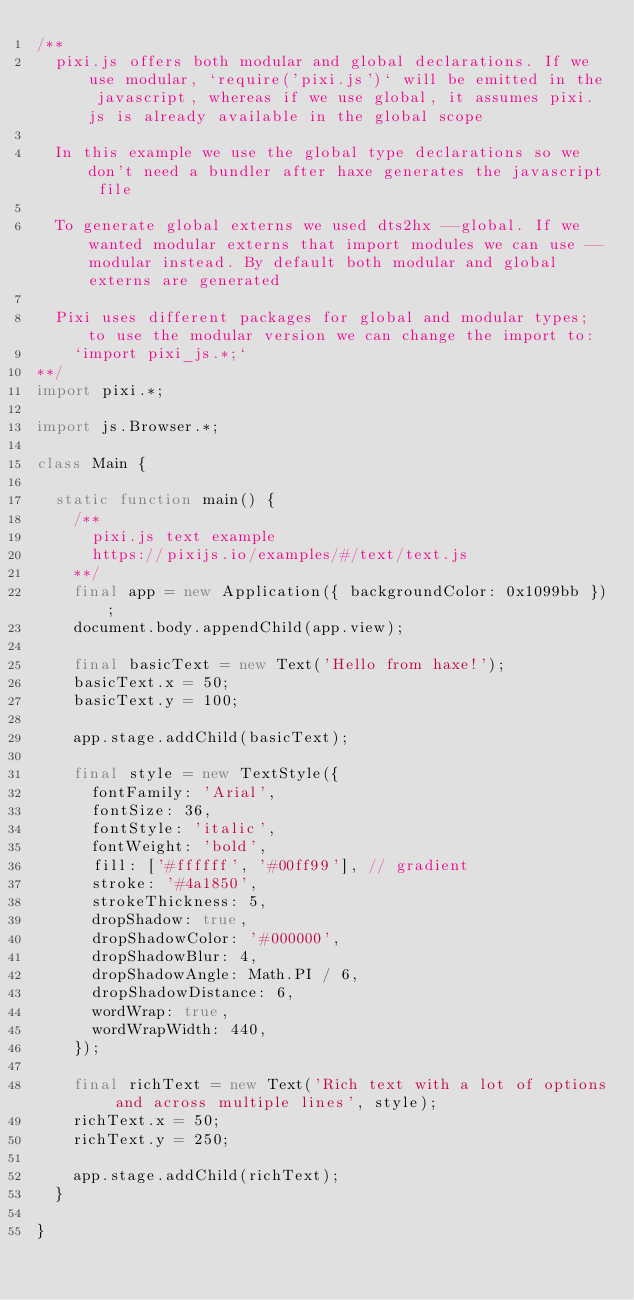Convert code to text. <code><loc_0><loc_0><loc_500><loc_500><_Haxe_>/**
	pixi.js offers both modular and global declarations. If we use modular, `require('pixi.js')` will be emitted in the javascript, whereas if we use global, it assumes pixi.js is already available in the global scope

	In this example we use the global type declarations so we don't need a bundler after haxe generates the javascript file

	To generate global externs we used dts2hx --global. If we wanted modular externs that import modules we can use --modular instead. By default both modular and global externs are generated

	Pixi uses different packages for global and modular types; to use the modular version we can change the import to:
		`import pixi_js.*;`
**/
import pixi.*;

import js.Browser.*;

class Main {

	static function main() {
		/**
			pixi.js text example
			https://pixijs.io/examples/#/text/text.js
		**/
		final app = new Application({ backgroundColor: 0x1099bb });
		document.body.appendChild(app.view);

		final basicText = new Text('Hello from haxe!');
		basicText.x = 50;
		basicText.y = 100;

		app.stage.addChild(basicText);

		final style = new TextStyle({
			fontFamily: 'Arial',
			fontSize: 36,
			fontStyle: 'italic',
			fontWeight: 'bold',
			fill: ['#ffffff', '#00ff99'], // gradient
			stroke: '#4a1850',
			strokeThickness: 5,
			dropShadow: true,
			dropShadowColor: '#000000',
			dropShadowBlur: 4,
			dropShadowAngle: Math.PI / 6,
			dropShadowDistance: 6,
			wordWrap: true,
			wordWrapWidth: 440,
		});

		final richText = new Text('Rich text with a lot of options and across multiple lines', style);
		richText.x = 50;
		richText.y = 250;

		app.stage.addChild(richText);
	}
	
}</code> 